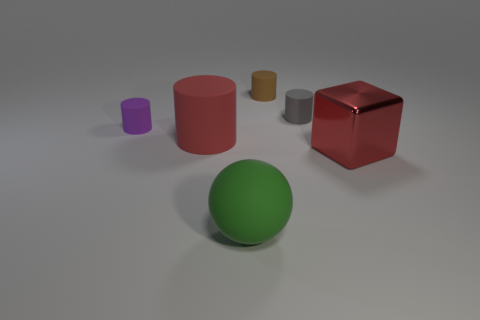Can you describe the colors of the objects in the picture? Certainly! In the image, we have a green sphere, a red cylinder, a purple small cylinder, a yellow small cylinder, a grey short cylinder, and a red shiny cube. 